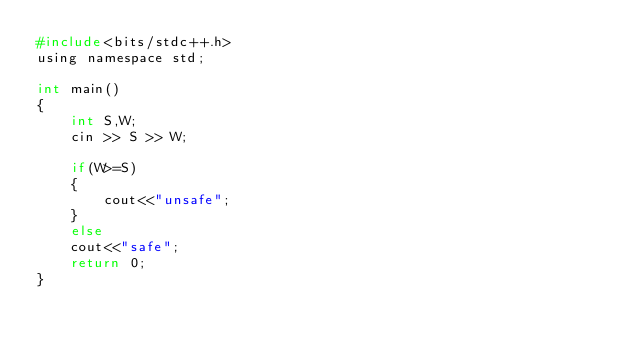<code> <loc_0><loc_0><loc_500><loc_500><_C_>#include<bits/stdc++.h>
using namespace std;

int main()
{
	int S,W;
	cin >> S >> W;
	
	if(W>=S)
	{
		cout<<"unsafe";
	}
	else
	cout<<"safe";
	return 0;
}</code> 